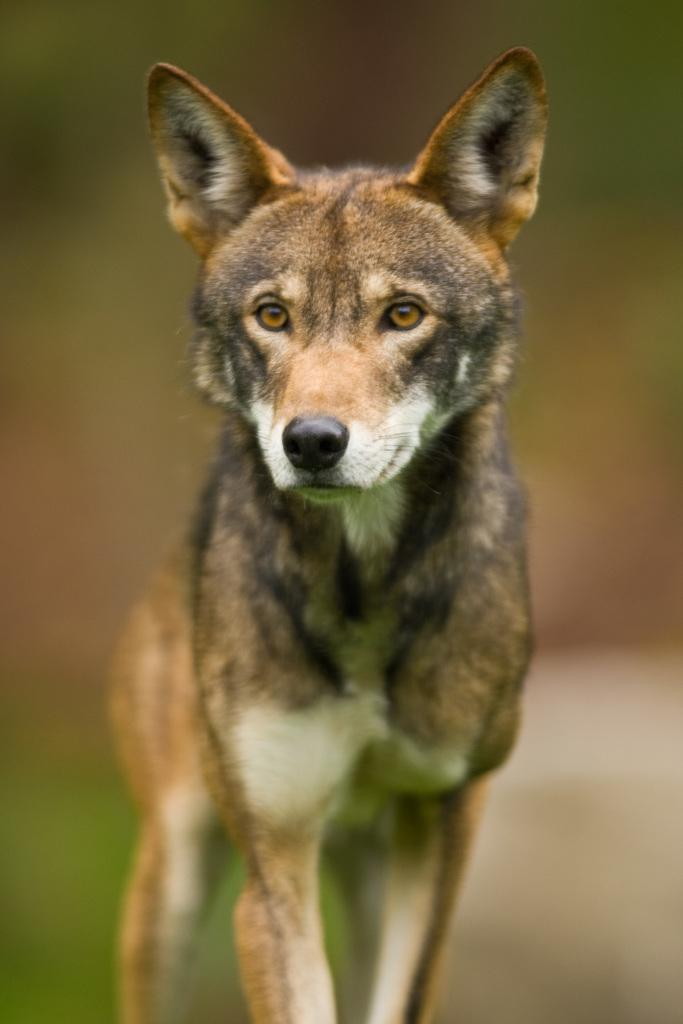What type of animal is in the image? There is a dog in the image. What color is the dog? The dog is brown in color. Can you describe the background of the image? The background of the image is blurred. What type of yak can be seen in the image? There is no yak present in the image; it features a brown dog. How does the dog rub its nose in the image? The image does not show the dog rubbing its nose, so it cannot be determined from the image. 